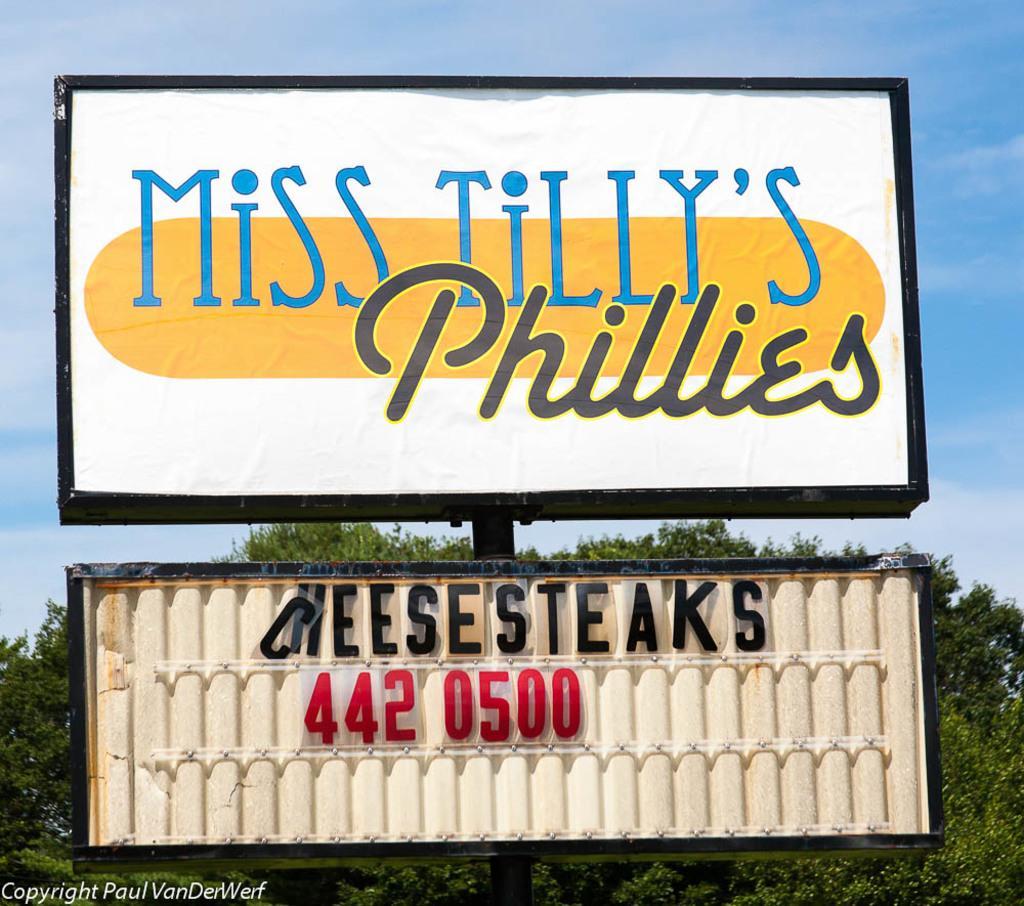Could you give a brief overview of what you see in this image? In this picture, there are two boards to a pole. On the boards, there is some text with colors. Behind it, there is a tree. In the background, there is a sky. 